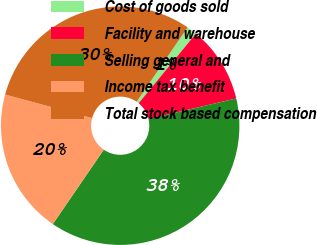Convert chart to OTSL. <chart><loc_0><loc_0><loc_500><loc_500><pie_chart><fcel>Cost of goods sold<fcel>Facility and warehouse<fcel>Selling general and<fcel>Income tax benefit<fcel>Total stock based compensation<nl><fcel>1.39%<fcel>10.37%<fcel>38.23%<fcel>19.65%<fcel>30.35%<nl></chart> 